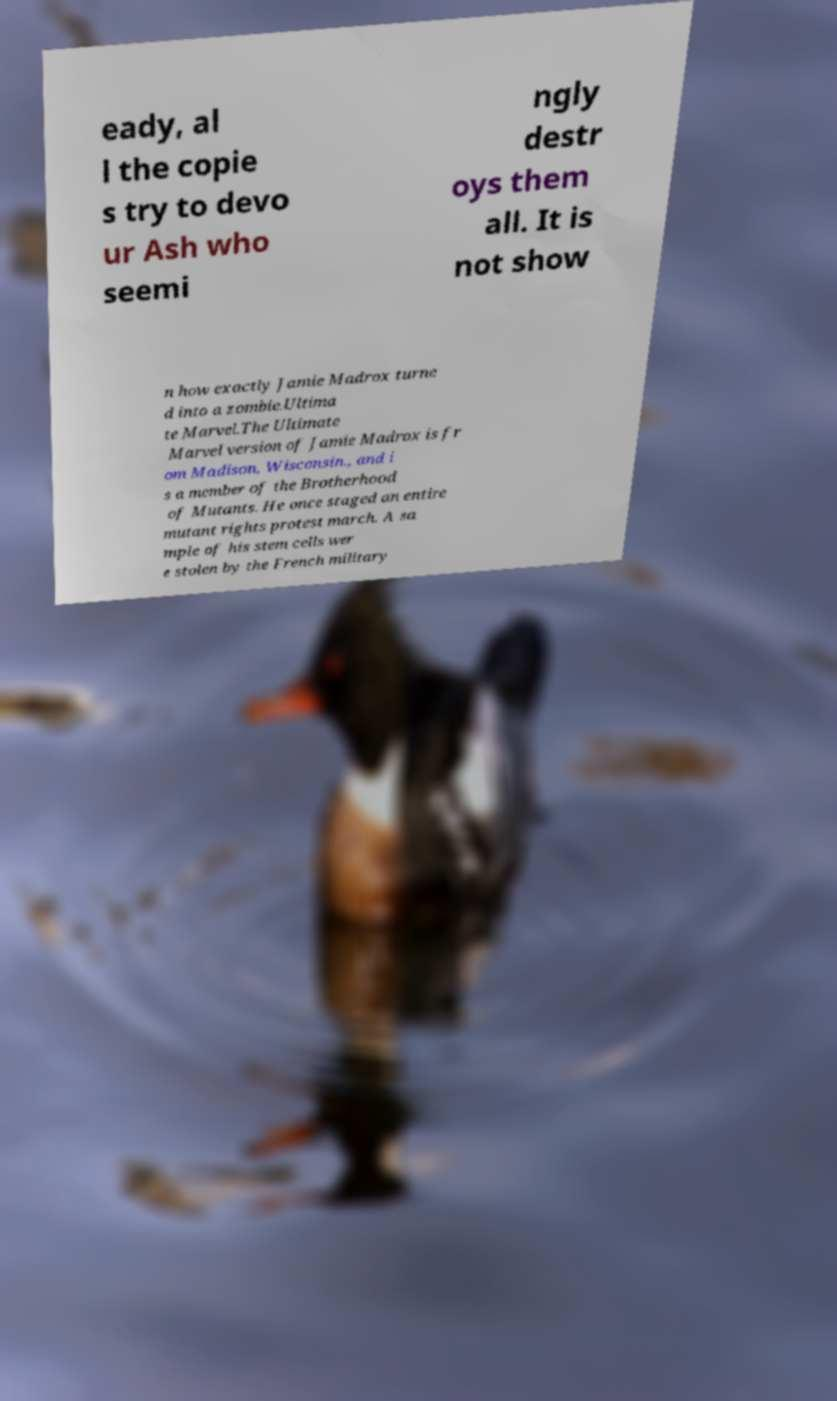Please read and relay the text visible in this image. What does it say? eady, al l the copie s try to devo ur Ash who seemi ngly destr oys them all. It is not show n how exactly Jamie Madrox turne d into a zombie.Ultima te Marvel.The Ultimate Marvel version of Jamie Madrox is fr om Madison, Wisconsin., and i s a member of the Brotherhood of Mutants. He once staged an entire mutant rights protest march. A sa mple of his stem cells wer e stolen by the French military 